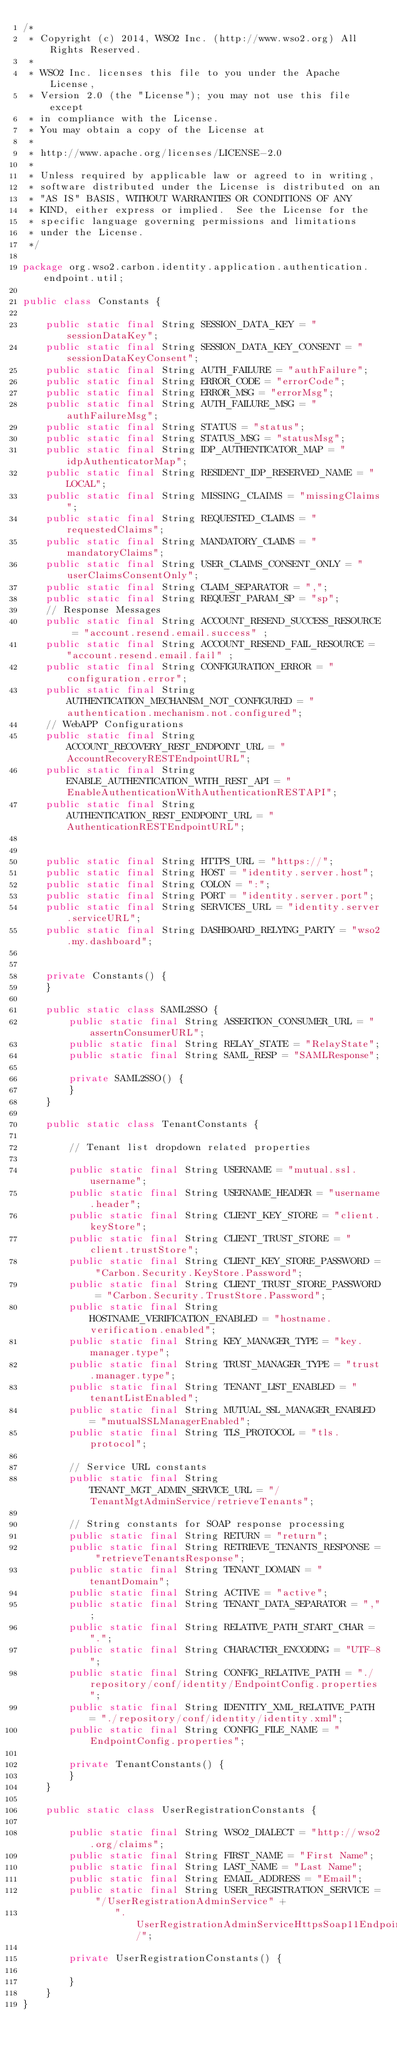<code> <loc_0><loc_0><loc_500><loc_500><_Java_>/*
 * Copyright (c) 2014, WSO2 Inc. (http://www.wso2.org) All Rights Reserved.
 *
 * WSO2 Inc. licenses this file to you under the Apache License,
 * Version 2.0 (the "License"); you may not use this file except
 * in compliance with the License.
 * You may obtain a copy of the License at
 *
 * http://www.apache.org/licenses/LICENSE-2.0
 *
 * Unless required by applicable law or agreed to in writing,
 * software distributed under the License is distributed on an
 * "AS IS" BASIS, WITHOUT WARRANTIES OR CONDITIONS OF ANY
 * KIND, either express or implied.  See the License for the
 * specific language governing permissions and limitations
 * under the License.
 */

package org.wso2.carbon.identity.application.authentication.endpoint.util;

public class Constants {

    public static final String SESSION_DATA_KEY = "sessionDataKey";
    public static final String SESSION_DATA_KEY_CONSENT = "sessionDataKeyConsent";
    public static final String AUTH_FAILURE = "authFailure";
    public static final String ERROR_CODE = "errorCode";
    public static final String ERROR_MSG = "errorMsg";
    public static final String AUTH_FAILURE_MSG = "authFailureMsg";
    public static final String STATUS = "status";
    public static final String STATUS_MSG = "statusMsg";
    public static final String IDP_AUTHENTICATOR_MAP = "idpAuthenticatorMap";
    public static final String RESIDENT_IDP_RESERVED_NAME = "LOCAL";
    public static final String MISSING_CLAIMS = "missingClaims";
    public static final String REQUESTED_CLAIMS = "requestedClaims";
    public static final String MANDATORY_CLAIMS = "mandatoryClaims";
    public static final String USER_CLAIMS_CONSENT_ONLY = "userClaimsConsentOnly";
    public static final String CLAIM_SEPARATOR = ",";
    public static final String REQUEST_PARAM_SP = "sp";
    // Response Messages
    public static final String ACCOUNT_RESEND_SUCCESS_RESOURCE = "account.resend.email.success" ;
    public static final String ACCOUNT_RESEND_FAIL_RESOURCE = "account.resend.email.fail" ;
    public static final String CONFIGURATION_ERROR = "configuration.error";
    public static final String AUTHENTICATION_MECHANISM_NOT_CONFIGURED = "authentication.mechanism.not.configured";
    // WebAPP Configurations
    public static final String ACCOUNT_RECOVERY_REST_ENDPOINT_URL = "AccountRecoveryRESTEndpointURL";
    public static final String ENABLE_AUTHENTICATION_WITH_REST_API = "EnableAuthenticationWithAuthenticationRESTAPI";
    public static final String AUTHENTICATION_REST_ENDPOINT_URL = "AuthenticationRESTEndpointURL";


    public static final String HTTPS_URL = "https://";
    public static final String HOST = "identity.server.host";
    public static final String COLON = ":";
    public static final String PORT = "identity.server.port";
    public static final String SERVICES_URL = "identity.server.serviceURL";
    public static final String DASHBOARD_RELYING_PARTY = "wso2.my.dashboard";


    private Constants() {
    }

    public static class SAML2SSO {
        public static final String ASSERTION_CONSUMER_URL = "assertnConsumerURL";
        public static final String RELAY_STATE = "RelayState";
        public static final String SAML_RESP = "SAMLResponse";

        private SAML2SSO() {
        }
    }

    public static class TenantConstants {

        // Tenant list dropdown related properties

        public static final String USERNAME = "mutual.ssl.username";
        public static final String USERNAME_HEADER = "username.header";
        public static final String CLIENT_KEY_STORE = "client.keyStore";
        public static final String CLIENT_TRUST_STORE = "client.trustStore";
        public static final String CLIENT_KEY_STORE_PASSWORD = "Carbon.Security.KeyStore.Password";
        public static final String CLIENT_TRUST_STORE_PASSWORD = "Carbon.Security.TrustStore.Password";
        public static final String HOSTNAME_VERIFICATION_ENABLED = "hostname.verification.enabled";
        public static final String KEY_MANAGER_TYPE = "key.manager.type";
        public static final String TRUST_MANAGER_TYPE = "trust.manager.type";
        public static final String TENANT_LIST_ENABLED = "tenantListEnabled";
        public static final String MUTUAL_SSL_MANAGER_ENABLED = "mutualSSLManagerEnabled";
        public static final String TLS_PROTOCOL = "tls.protocol";

        // Service URL constants
        public static final String TENANT_MGT_ADMIN_SERVICE_URL = "/TenantMgtAdminService/retrieveTenants";

        // String constants for SOAP response processing
        public static final String RETURN = "return";
        public static final String RETRIEVE_TENANTS_RESPONSE = "retrieveTenantsResponse";
        public static final String TENANT_DOMAIN = "tenantDomain";
        public static final String ACTIVE = "active";
        public static final String TENANT_DATA_SEPARATOR = ",";
        public static final String RELATIVE_PATH_START_CHAR = ".";
        public static final String CHARACTER_ENCODING = "UTF-8";
        public static final String CONFIG_RELATIVE_PATH = "./repository/conf/identity/EndpointConfig.properties";
        public static final String IDENTITY_XML_RELATIVE_PATH = "./repository/conf/identity/identity.xml";
        public static final String CONFIG_FILE_NAME = "EndpointConfig.properties";

        private TenantConstants() {
        }
    }

    public static class UserRegistrationConstants {

        public static final String WSO2_DIALECT = "http://wso2.org/claims";
        public static final String FIRST_NAME = "First Name";
        public static final String LAST_NAME = "Last Name";
        public static final String EMAIL_ADDRESS = "Email";
        public static final String USER_REGISTRATION_SERVICE = "/UserRegistrationAdminService" +
                ".UserRegistrationAdminServiceHttpsSoap11Endpoint/";

        private UserRegistrationConstants() {

        }
    }
}
</code> 